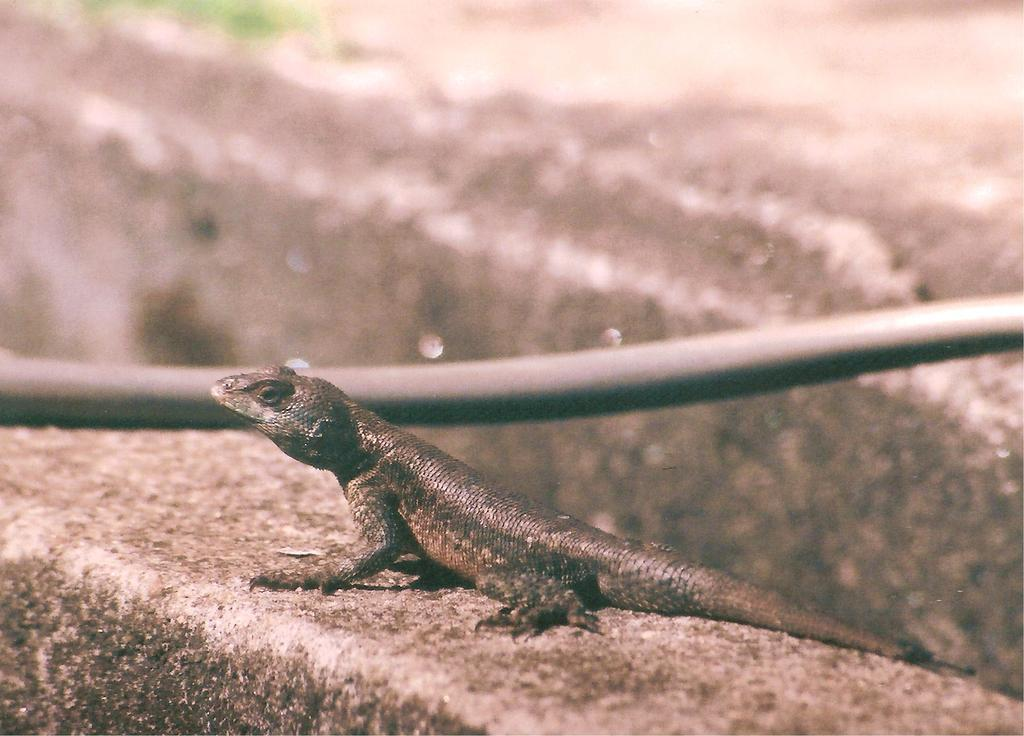What type of animal is in the image? There is a lizard in the image. What is the lizard doing in the image? The lizard is laying on a surface. What type of root can be seen growing from the lizard's tail in the image? There is no root growing from the lizard's tail in the image, as lizards do not have roots. 